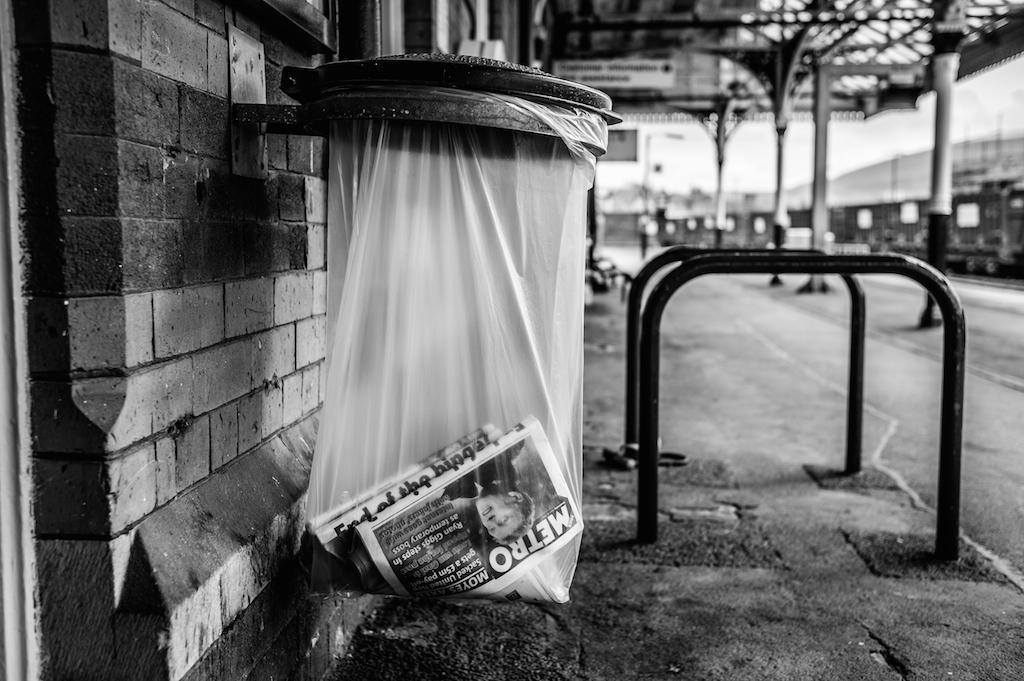<image>
Present a compact description of the photo's key features. The outside of a building and a sack of trash with a paper in it that has the word Metro on it. 